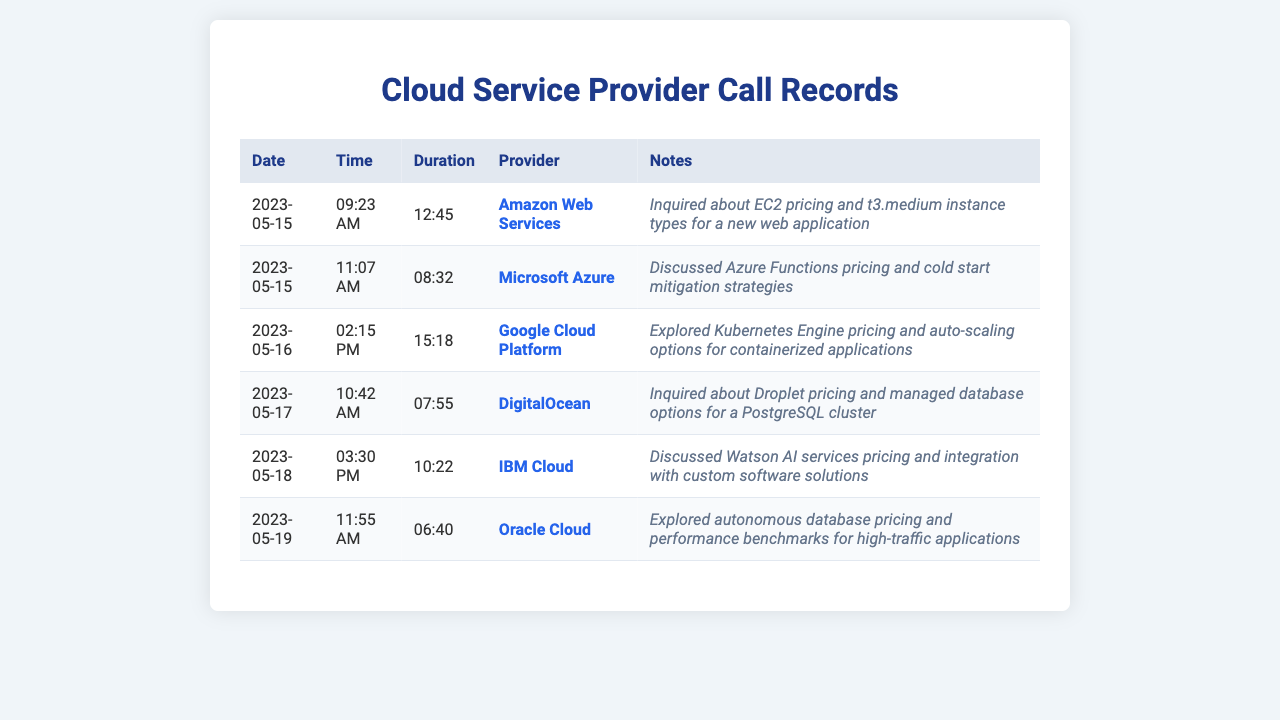What is the date of the first call? The first call in the records took place on May 15, 2023.
Answer: May 15, 2023 Which provider was called on May 18, 2023? On May 18, 2023, the call was made to IBM Cloud.
Answer: IBM Cloud What was the duration of the call to DigitalOcean? The call to DigitalOcean lasted for 7 minutes and 55 seconds.
Answer: 07:55 How many total calls were made to cloud service providers? There are a total of 6 calls listed in the records.
Answer: 6 Which provider discussed pricing for Kubernetes Engine? Google Cloud Platform was the provider that discussed Kubernetes Engine pricing.
Answer: Google Cloud Platform What was inquired about during the call to Oracle Cloud? The inquiry was about autonomous database pricing and performance benchmarks.
Answer: Autonomous database pricing and performance benchmarks Which call had the longest duration? The call on May 16, 2023, to Google Cloud Platform lasted the longest at 15 minutes and 18 seconds.
Answer: 15:18 What type of instance was specifically mentioned during the AWS call? The t3.medium instance type was mentioned during the AWS call.
Answer: t3.medium On which date was the call to Microsoft Azure made? The call to Microsoft Azure was made on May 15, 2023.
Answer: May 15, 2023 